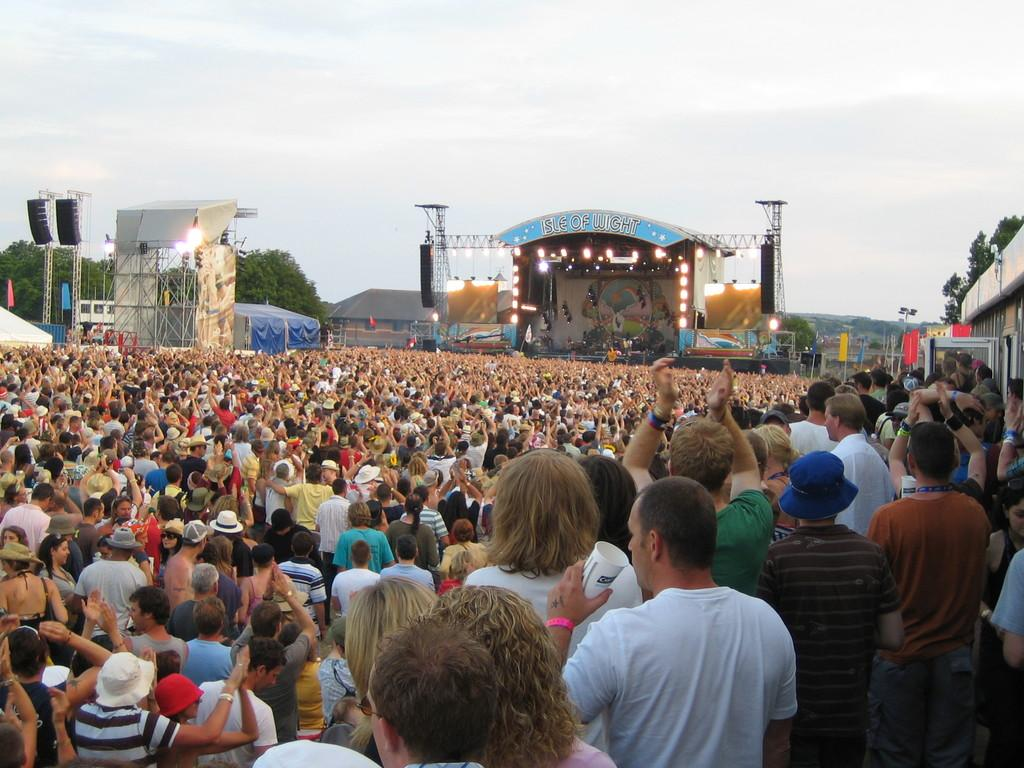How many people are in the image? There are people in the image, but the exact number is not specified. What is located in the background of the image? In the background of the image, there is a stage, lights, flags, a board, rods, trees, objects, sheds, and the sky. What type of objects can be seen in the background of the image? The objects in the background of the image are not specified. What is the color of the sky in the image? The color of the sky in the image is not specified. What type of stone is used to build the nation in the image? There is no nation or stone present in the image. What type of fork can be seen in the hands of the people in the image? There is no fork present in the image. 